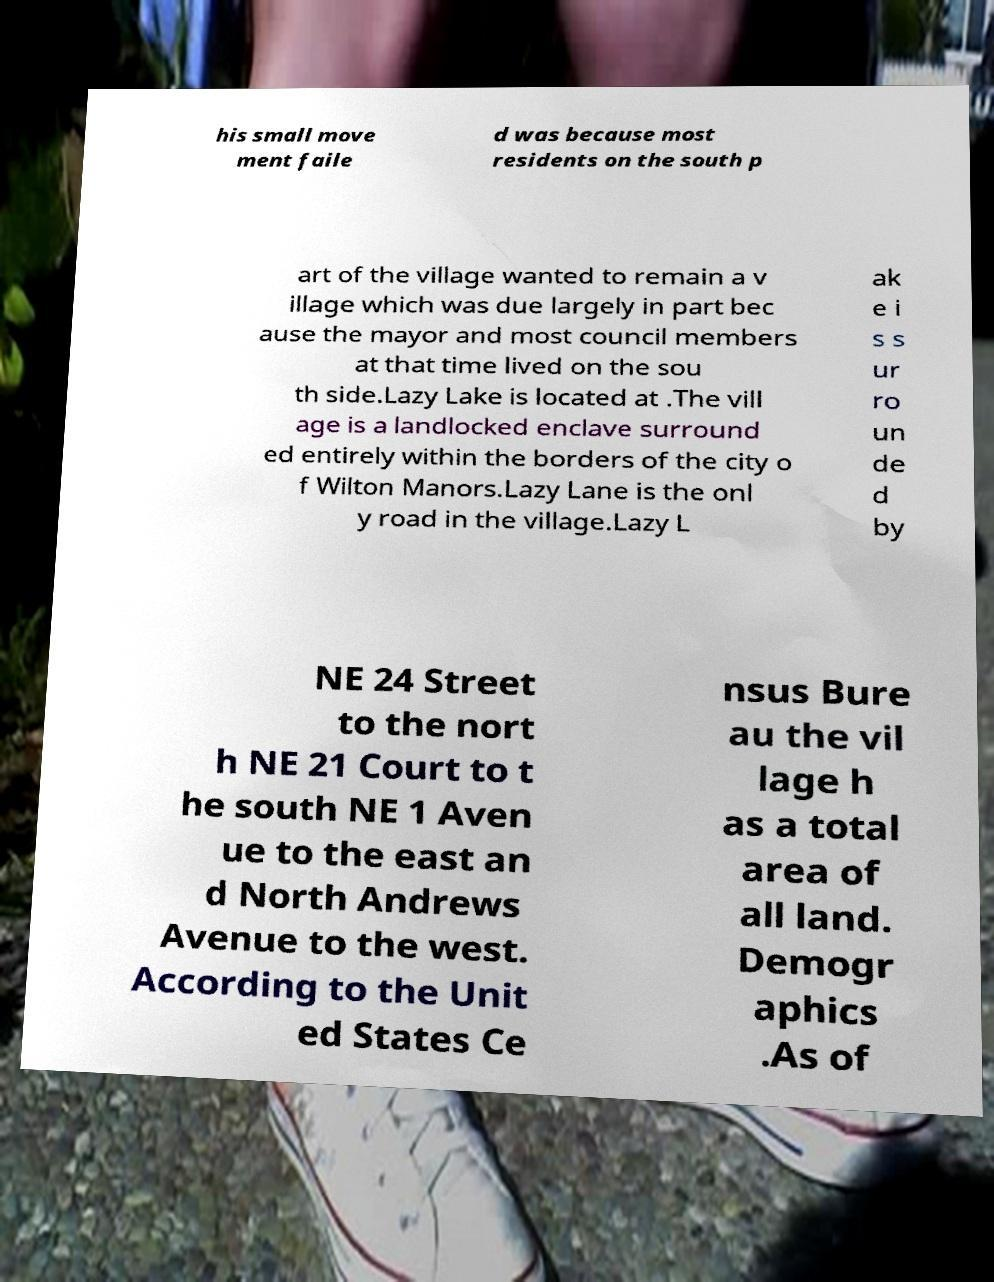For documentation purposes, I need the text within this image transcribed. Could you provide that? his small move ment faile d was because most residents on the south p art of the village wanted to remain a v illage which was due largely in part bec ause the mayor and most council members at that time lived on the sou th side.Lazy Lake is located at .The vill age is a landlocked enclave surround ed entirely within the borders of the city o f Wilton Manors.Lazy Lane is the onl y road in the village.Lazy L ak e i s s ur ro un de d by NE 24 Street to the nort h NE 21 Court to t he south NE 1 Aven ue to the east an d North Andrews Avenue to the west. According to the Unit ed States Ce nsus Bure au the vil lage h as a total area of all land. Demogr aphics .As of 